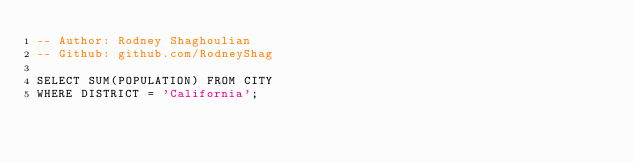Convert code to text. <code><loc_0><loc_0><loc_500><loc_500><_SQL_>-- Author: Rodney Shaghoulian
-- Github: github.com/RodneyShag

SELECT SUM(POPULATION) FROM CITY
WHERE DISTRICT = 'California';
</code> 